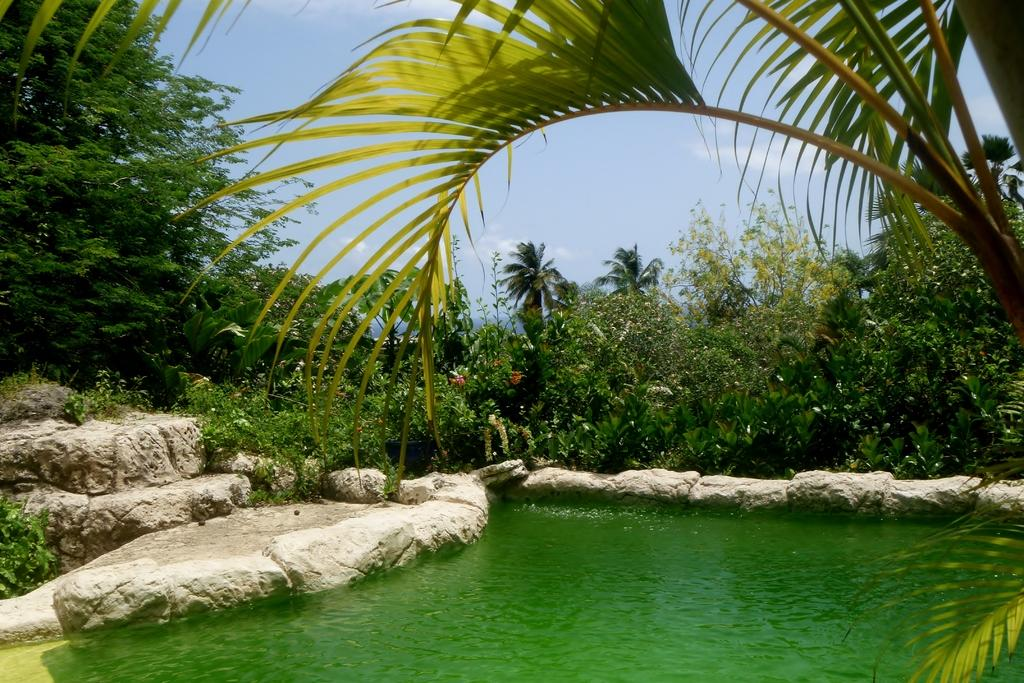What is the primary element in the picture? There is water in the picture. What is the color of the water? The water is green in color. What is located near the water? There is a rock near the water. What type of vegetation can be seen in the image? There are plants and trees visible in the image. What is visible in the sky? The sky is visible in the image, and clouds are present. What type of plantation can be seen in the image? There is no plantation present in the image. What scientific experiment is being conducted in the image? There is no scientific experiment visible in the image. 